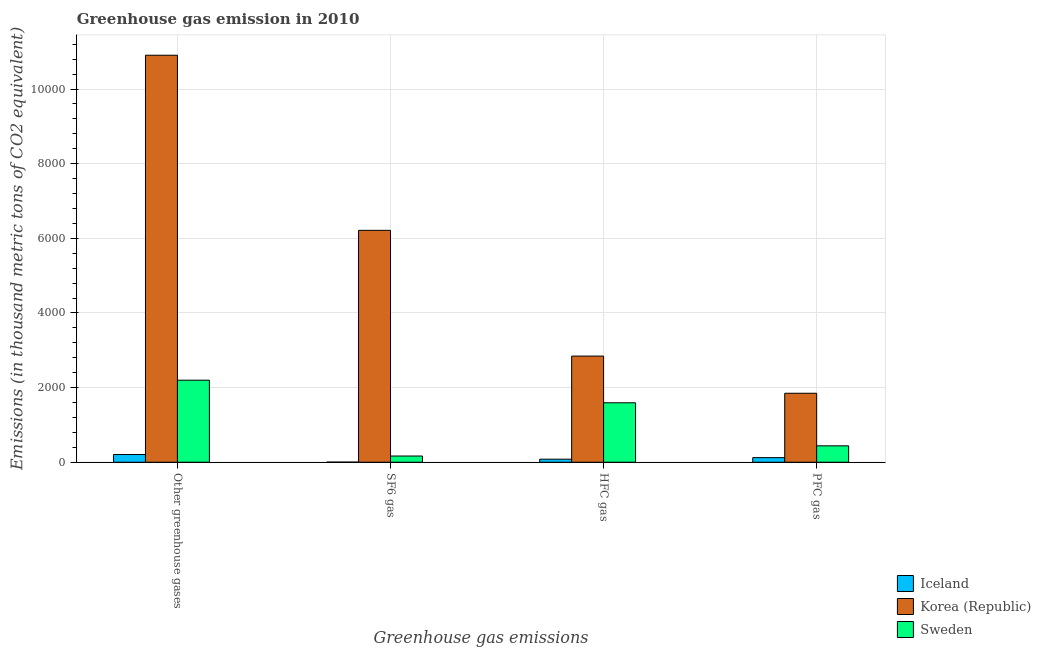How many different coloured bars are there?
Your answer should be very brief. 3. Are the number of bars on each tick of the X-axis equal?
Offer a very short reply. Yes. How many bars are there on the 4th tick from the left?
Make the answer very short. 3. How many bars are there on the 4th tick from the right?
Ensure brevity in your answer.  3. What is the label of the 4th group of bars from the left?
Provide a succinct answer. PFC gas. What is the emission of pfc gas in Iceland?
Keep it short and to the point. 123. Across all countries, what is the maximum emission of hfc gas?
Provide a succinct answer. 2844. Across all countries, what is the minimum emission of pfc gas?
Offer a terse response. 123. In which country was the emission of pfc gas maximum?
Offer a very short reply. Korea (Republic). In which country was the emission of sf6 gas minimum?
Provide a succinct answer. Iceland. What is the total emission of sf6 gas in the graph?
Keep it short and to the point. 6382. What is the difference between the emission of pfc gas in Korea (Republic) and that in Sweden?
Offer a terse response. 1409. What is the difference between the emission of sf6 gas in Korea (Republic) and the emission of greenhouse gases in Iceland?
Provide a succinct answer. 6006. What is the average emission of sf6 gas per country?
Your answer should be compact. 2127.33. What is the difference between the emission of pfc gas and emission of greenhouse gases in Korea (Republic)?
Ensure brevity in your answer.  -9057. In how many countries, is the emission of sf6 gas greater than 9600 thousand metric tons?
Give a very brief answer. 0. What is the ratio of the emission of sf6 gas in Sweden to that in Iceland?
Keep it short and to the point. 55.33. Is the emission of sf6 gas in Korea (Republic) less than that in Iceland?
Provide a short and direct response. No. Is the difference between the emission of hfc gas in Iceland and Korea (Republic) greater than the difference between the emission of pfc gas in Iceland and Korea (Republic)?
Your answer should be very brief. No. What is the difference between the highest and the second highest emission of hfc gas?
Keep it short and to the point. 1251. What is the difference between the highest and the lowest emission of hfc gas?
Keep it short and to the point. 2763. In how many countries, is the emission of pfc gas greater than the average emission of pfc gas taken over all countries?
Your answer should be compact. 1. Is it the case that in every country, the sum of the emission of pfc gas and emission of hfc gas is greater than the sum of emission of greenhouse gases and emission of sf6 gas?
Provide a short and direct response. No. What does the 1st bar from the left in PFC gas represents?
Make the answer very short. Iceland. Is it the case that in every country, the sum of the emission of greenhouse gases and emission of sf6 gas is greater than the emission of hfc gas?
Keep it short and to the point. Yes. How many bars are there?
Keep it short and to the point. 12. Are the values on the major ticks of Y-axis written in scientific E-notation?
Give a very brief answer. No. How are the legend labels stacked?
Your answer should be very brief. Vertical. What is the title of the graph?
Make the answer very short. Greenhouse gas emission in 2010. Does "Lesotho" appear as one of the legend labels in the graph?
Give a very brief answer. No. What is the label or title of the X-axis?
Your response must be concise. Greenhouse gas emissions. What is the label or title of the Y-axis?
Keep it short and to the point. Emissions (in thousand metric tons of CO2 equivalent). What is the Emissions (in thousand metric tons of CO2 equivalent) in Iceland in Other greenhouse gases?
Your answer should be very brief. 207. What is the Emissions (in thousand metric tons of CO2 equivalent) of Korea (Republic) in Other greenhouse gases?
Make the answer very short. 1.09e+04. What is the Emissions (in thousand metric tons of CO2 equivalent) of Sweden in Other greenhouse gases?
Offer a very short reply. 2198. What is the Emissions (in thousand metric tons of CO2 equivalent) in Iceland in SF6 gas?
Offer a very short reply. 3. What is the Emissions (in thousand metric tons of CO2 equivalent) of Korea (Republic) in SF6 gas?
Make the answer very short. 6213. What is the Emissions (in thousand metric tons of CO2 equivalent) in Sweden in SF6 gas?
Your answer should be compact. 166. What is the Emissions (in thousand metric tons of CO2 equivalent) of Korea (Republic) in HFC gas?
Provide a succinct answer. 2844. What is the Emissions (in thousand metric tons of CO2 equivalent) in Sweden in HFC gas?
Offer a very short reply. 1593. What is the Emissions (in thousand metric tons of CO2 equivalent) in Iceland in PFC gas?
Your response must be concise. 123. What is the Emissions (in thousand metric tons of CO2 equivalent) of Korea (Republic) in PFC gas?
Offer a terse response. 1848. What is the Emissions (in thousand metric tons of CO2 equivalent) of Sweden in PFC gas?
Make the answer very short. 439. Across all Greenhouse gas emissions, what is the maximum Emissions (in thousand metric tons of CO2 equivalent) in Iceland?
Offer a terse response. 207. Across all Greenhouse gas emissions, what is the maximum Emissions (in thousand metric tons of CO2 equivalent) in Korea (Republic)?
Ensure brevity in your answer.  1.09e+04. Across all Greenhouse gas emissions, what is the maximum Emissions (in thousand metric tons of CO2 equivalent) in Sweden?
Keep it short and to the point. 2198. Across all Greenhouse gas emissions, what is the minimum Emissions (in thousand metric tons of CO2 equivalent) in Iceland?
Offer a very short reply. 3. Across all Greenhouse gas emissions, what is the minimum Emissions (in thousand metric tons of CO2 equivalent) in Korea (Republic)?
Your response must be concise. 1848. Across all Greenhouse gas emissions, what is the minimum Emissions (in thousand metric tons of CO2 equivalent) in Sweden?
Offer a terse response. 166. What is the total Emissions (in thousand metric tons of CO2 equivalent) of Iceland in the graph?
Offer a very short reply. 414. What is the total Emissions (in thousand metric tons of CO2 equivalent) in Korea (Republic) in the graph?
Your answer should be very brief. 2.18e+04. What is the total Emissions (in thousand metric tons of CO2 equivalent) in Sweden in the graph?
Offer a very short reply. 4396. What is the difference between the Emissions (in thousand metric tons of CO2 equivalent) of Iceland in Other greenhouse gases and that in SF6 gas?
Provide a succinct answer. 204. What is the difference between the Emissions (in thousand metric tons of CO2 equivalent) in Korea (Republic) in Other greenhouse gases and that in SF6 gas?
Make the answer very short. 4692. What is the difference between the Emissions (in thousand metric tons of CO2 equivalent) of Sweden in Other greenhouse gases and that in SF6 gas?
Provide a short and direct response. 2032. What is the difference between the Emissions (in thousand metric tons of CO2 equivalent) in Iceland in Other greenhouse gases and that in HFC gas?
Offer a very short reply. 126. What is the difference between the Emissions (in thousand metric tons of CO2 equivalent) of Korea (Republic) in Other greenhouse gases and that in HFC gas?
Your answer should be very brief. 8061. What is the difference between the Emissions (in thousand metric tons of CO2 equivalent) of Sweden in Other greenhouse gases and that in HFC gas?
Your response must be concise. 605. What is the difference between the Emissions (in thousand metric tons of CO2 equivalent) of Korea (Republic) in Other greenhouse gases and that in PFC gas?
Your answer should be very brief. 9057. What is the difference between the Emissions (in thousand metric tons of CO2 equivalent) of Sweden in Other greenhouse gases and that in PFC gas?
Make the answer very short. 1759. What is the difference between the Emissions (in thousand metric tons of CO2 equivalent) in Iceland in SF6 gas and that in HFC gas?
Offer a very short reply. -78. What is the difference between the Emissions (in thousand metric tons of CO2 equivalent) of Korea (Republic) in SF6 gas and that in HFC gas?
Your answer should be very brief. 3369. What is the difference between the Emissions (in thousand metric tons of CO2 equivalent) in Sweden in SF6 gas and that in HFC gas?
Make the answer very short. -1427. What is the difference between the Emissions (in thousand metric tons of CO2 equivalent) of Iceland in SF6 gas and that in PFC gas?
Your answer should be compact. -120. What is the difference between the Emissions (in thousand metric tons of CO2 equivalent) of Korea (Republic) in SF6 gas and that in PFC gas?
Keep it short and to the point. 4365. What is the difference between the Emissions (in thousand metric tons of CO2 equivalent) in Sweden in SF6 gas and that in PFC gas?
Give a very brief answer. -273. What is the difference between the Emissions (in thousand metric tons of CO2 equivalent) of Iceland in HFC gas and that in PFC gas?
Make the answer very short. -42. What is the difference between the Emissions (in thousand metric tons of CO2 equivalent) in Korea (Republic) in HFC gas and that in PFC gas?
Your answer should be very brief. 996. What is the difference between the Emissions (in thousand metric tons of CO2 equivalent) in Sweden in HFC gas and that in PFC gas?
Offer a very short reply. 1154. What is the difference between the Emissions (in thousand metric tons of CO2 equivalent) in Iceland in Other greenhouse gases and the Emissions (in thousand metric tons of CO2 equivalent) in Korea (Republic) in SF6 gas?
Make the answer very short. -6006. What is the difference between the Emissions (in thousand metric tons of CO2 equivalent) in Iceland in Other greenhouse gases and the Emissions (in thousand metric tons of CO2 equivalent) in Sweden in SF6 gas?
Offer a terse response. 41. What is the difference between the Emissions (in thousand metric tons of CO2 equivalent) of Korea (Republic) in Other greenhouse gases and the Emissions (in thousand metric tons of CO2 equivalent) of Sweden in SF6 gas?
Make the answer very short. 1.07e+04. What is the difference between the Emissions (in thousand metric tons of CO2 equivalent) of Iceland in Other greenhouse gases and the Emissions (in thousand metric tons of CO2 equivalent) of Korea (Republic) in HFC gas?
Ensure brevity in your answer.  -2637. What is the difference between the Emissions (in thousand metric tons of CO2 equivalent) of Iceland in Other greenhouse gases and the Emissions (in thousand metric tons of CO2 equivalent) of Sweden in HFC gas?
Give a very brief answer. -1386. What is the difference between the Emissions (in thousand metric tons of CO2 equivalent) in Korea (Republic) in Other greenhouse gases and the Emissions (in thousand metric tons of CO2 equivalent) in Sweden in HFC gas?
Keep it short and to the point. 9312. What is the difference between the Emissions (in thousand metric tons of CO2 equivalent) in Iceland in Other greenhouse gases and the Emissions (in thousand metric tons of CO2 equivalent) in Korea (Republic) in PFC gas?
Ensure brevity in your answer.  -1641. What is the difference between the Emissions (in thousand metric tons of CO2 equivalent) in Iceland in Other greenhouse gases and the Emissions (in thousand metric tons of CO2 equivalent) in Sweden in PFC gas?
Your answer should be very brief. -232. What is the difference between the Emissions (in thousand metric tons of CO2 equivalent) in Korea (Republic) in Other greenhouse gases and the Emissions (in thousand metric tons of CO2 equivalent) in Sweden in PFC gas?
Give a very brief answer. 1.05e+04. What is the difference between the Emissions (in thousand metric tons of CO2 equivalent) of Iceland in SF6 gas and the Emissions (in thousand metric tons of CO2 equivalent) of Korea (Republic) in HFC gas?
Your answer should be very brief. -2841. What is the difference between the Emissions (in thousand metric tons of CO2 equivalent) in Iceland in SF6 gas and the Emissions (in thousand metric tons of CO2 equivalent) in Sweden in HFC gas?
Provide a succinct answer. -1590. What is the difference between the Emissions (in thousand metric tons of CO2 equivalent) in Korea (Republic) in SF6 gas and the Emissions (in thousand metric tons of CO2 equivalent) in Sweden in HFC gas?
Offer a very short reply. 4620. What is the difference between the Emissions (in thousand metric tons of CO2 equivalent) of Iceland in SF6 gas and the Emissions (in thousand metric tons of CO2 equivalent) of Korea (Republic) in PFC gas?
Offer a terse response. -1845. What is the difference between the Emissions (in thousand metric tons of CO2 equivalent) in Iceland in SF6 gas and the Emissions (in thousand metric tons of CO2 equivalent) in Sweden in PFC gas?
Provide a succinct answer. -436. What is the difference between the Emissions (in thousand metric tons of CO2 equivalent) in Korea (Republic) in SF6 gas and the Emissions (in thousand metric tons of CO2 equivalent) in Sweden in PFC gas?
Your answer should be compact. 5774. What is the difference between the Emissions (in thousand metric tons of CO2 equivalent) of Iceland in HFC gas and the Emissions (in thousand metric tons of CO2 equivalent) of Korea (Republic) in PFC gas?
Give a very brief answer. -1767. What is the difference between the Emissions (in thousand metric tons of CO2 equivalent) in Iceland in HFC gas and the Emissions (in thousand metric tons of CO2 equivalent) in Sweden in PFC gas?
Provide a succinct answer. -358. What is the difference between the Emissions (in thousand metric tons of CO2 equivalent) of Korea (Republic) in HFC gas and the Emissions (in thousand metric tons of CO2 equivalent) of Sweden in PFC gas?
Keep it short and to the point. 2405. What is the average Emissions (in thousand metric tons of CO2 equivalent) in Iceland per Greenhouse gas emissions?
Ensure brevity in your answer.  103.5. What is the average Emissions (in thousand metric tons of CO2 equivalent) of Korea (Republic) per Greenhouse gas emissions?
Offer a terse response. 5452.5. What is the average Emissions (in thousand metric tons of CO2 equivalent) of Sweden per Greenhouse gas emissions?
Give a very brief answer. 1099. What is the difference between the Emissions (in thousand metric tons of CO2 equivalent) of Iceland and Emissions (in thousand metric tons of CO2 equivalent) of Korea (Republic) in Other greenhouse gases?
Your answer should be very brief. -1.07e+04. What is the difference between the Emissions (in thousand metric tons of CO2 equivalent) of Iceland and Emissions (in thousand metric tons of CO2 equivalent) of Sweden in Other greenhouse gases?
Provide a short and direct response. -1991. What is the difference between the Emissions (in thousand metric tons of CO2 equivalent) in Korea (Republic) and Emissions (in thousand metric tons of CO2 equivalent) in Sweden in Other greenhouse gases?
Your answer should be very brief. 8707. What is the difference between the Emissions (in thousand metric tons of CO2 equivalent) of Iceland and Emissions (in thousand metric tons of CO2 equivalent) of Korea (Republic) in SF6 gas?
Provide a succinct answer. -6210. What is the difference between the Emissions (in thousand metric tons of CO2 equivalent) of Iceland and Emissions (in thousand metric tons of CO2 equivalent) of Sweden in SF6 gas?
Ensure brevity in your answer.  -163. What is the difference between the Emissions (in thousand metric tons of CO2 equivalent) of Korea (Republic) and Emissions (in thousand metric tons of CO2 equivalent) of Sweden in SF6 gas?
Provide a succinct answer. 6047. What is the difference between the Emissions (in thousand metric tons of CO2 equivalent) of Iceland and Emissions (in thousand metric tons of CO2 equivalent) of Korea (Republic) in HFC gas?
Keep it short and to the point. -2763. What is the difference between the Emissions (in thousand metric tons of CO2 equivalent) in Iceland and Emissions (in thousand metric tons of CO2 equivalent) in Sweden in HFC gas?
Give a very brief answer. -1512. What is the difference between the Emissions (in thousand metric tons of CO2 equivalent) in Korea (Republic) and Emissions (in thousand metric tons of CO2 equivalent) in Sweden in HFC gas?
Give a very brief answer. 1251. What is the difference between the Emissions (in thousand metric tons of CO2 equivalent) in Iceland and Emissions (in thousand metric tons of CO2 equivalent) in Korea (Republic) in PFC gas?
Provide a short and direct response. -1725. What is the difference between the Emissions (in thousand metric tons of CO2 equivalent) in Iceland and Emissions (in thousand metric tons of CO2 equivalent) in Sweden in PFC gas?
Offer a terse response. -316. What is the difference between the Emissions (in thousand metric tons of CO2 equivalent) in Korea (Republic) and Emissions (in thousand metric tons of CO2 equivalent) in Sweden in PFC gas?
Offer a terse response. 1409. What is the ratio of the Emissions (in thousand metric tons of CO2 equivalent) in Iceland in Other greenhouse gases to that in SF6 gas?
Keep it short and to the point. 69. What is the ratio of the Emissions (in thousand metric tons of CO2 equivalent) of Korea (Republic) in Other greenhouse gases to that in SF6 gas?
Provide a short and direct response. 1.76. What is the ratio of the Emissions (in thousand metric tons of CO2 equivalent) in Sweden in Other greenhouse gases to that in SF6 gas?
Your answer should be compact. 13.24. What is the ratio of the Emissions (in thousand metric tons of CO2 equivalent) of Iceland in Other greenhouse gases to that in HFC gas?
Keep it short and to the point. 2.56. What is the ratio of the Emissions (in thousand metric tons of CO2 equivalent) in Korea (Republic) in Other greenhouse gases to that in HFC gas?
Your answer should be very brief. 3.83. What is the ratio of the Emissions (in thousand metric tons of CO2 equivalent) of Sweden in Other greenhouse gases to that in HFC gas?
Ensure brevity in your answer.  1.38. What is the ratio of the Emissions (in thousand metric tons of CO2 equivalent) in Iceland in Other greenhouse gases to that in PFC gas?
Offer a very short reply. 1.68. What is the ratio of the Emissions (in thousand metric tons of CO2 equivalent) in Korea (Republic) in Other greenhouse gases to that in PFC gas?
Your answer should be very brief. 5.9. What is the ratio of the Emissions (in thousand metric tons of CO2 equivalent) in Sweden in Other greenhouse gases to that in PFC gas?
Offer a very short reply. 5.01. What is the ratio of the Emissions (in thousand metric tons of CO2 equivalent) in Iceland in SF6 gas to that in HFC gas?
Ensure brevity in your answer.  0.04. What is the ratio of the Emissions (in thousand metric tons of CO2 equivalent) in Korea (Republic) in SF6 gas to that in HFC gas?
Provide a succinct answer. 2.18. What is the ratio of the Emissions (in thousand metric tons of CO2 equivalent) of Sweden in SF6 gas to that in HFC gas?
Make the answer very short. 0.1. What is the ratio of the Emissions (in thousand metric tons of CO2 equivalent) in Iceland in SF6 gas to that in PFC gas?
Your response must be concise. 0.02. What is the ratio of the Emissions (in thousand metric tons of CO2 equivalent) of Korea (Republic) in SF6 gas to that in PFC gas?
Ensure brevity in your answer.  3.36. What is the ratio of the Emissions (in thousand metric tons of CO2 equivalent) of Sweden in SF6 gas to that in PFC gas?
Offer a very short reply. 0.38. What is the ratio of the Emissions (in thousand metric tons of CO2 equivalent) in Iceland in HFC gas to that in PFC gas?
Keep it short and to the point. 0.66. What is the ratio of the Emissions (in thousand metric tons of CO2 equivalent) of Korea (Republic) in HFC gas to that in PFC gas?
Make the answer very short. 1.54. What is the ratio of the Emissions (in thousand metric tons of CO2 equivalent) of Sweden in HFC gas to that in PFC gas?
Your response must be concise. 3.63. What is the difference between the highest and the second highest Emissions (in thousand metric tons of CO2 equivalent) in Iceland?
Provide a short and direct response. 84. What is the difference between the highest and the second highest Emissions (in thousand metric tons of CO2 equivalent) of Korea (Republic)?
Ensure brevity in your answer.  4692. What is the difference between the highest and the second highest Emissions (in thousand metric tons of CO2 equivalent) in Sweden?
Your response must be concise. 605. What is the difference between the highest and the lowest Emissions (in thousand metric tons of CO2 equivalent) in Iceland?
Ensure brevity in your answer.  204. What is the difference between the highest and the lowest Emissions (in thousand metric tons of CO2 equivalent) of Korea (Republic)?
Your response must be concise. 9057. What is the difference between the highest and the lowest Emissions (in thousand metric tons of CO2 equivalent) in Sweden?
Provide a succinct answer. 2032. 